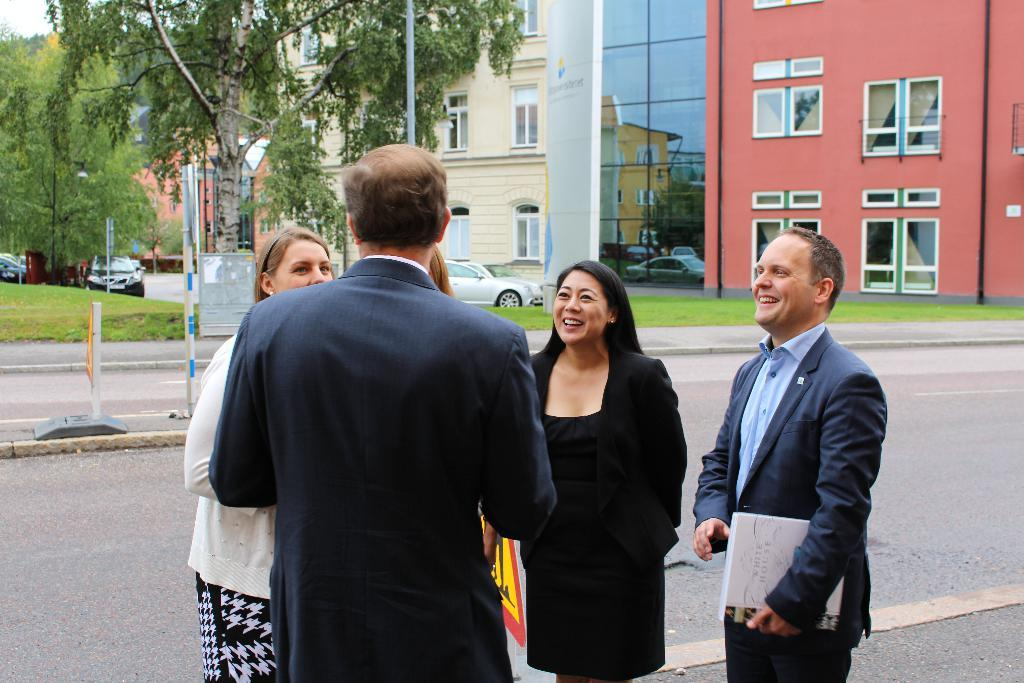What are the people in the image doing? The people in the image are standing on the road. What else can be seen in the image besides the people? Boards and parked vehicles are visible in the image. What type of vegetation is present in the image? There is grass and trees visible in the image. What is in the background of the image? There is a building in the background of the image. What type of meat is being served on the boards in the image? There are no boards with meat present in the image; the boards are likely used for advertising or display purposes. 